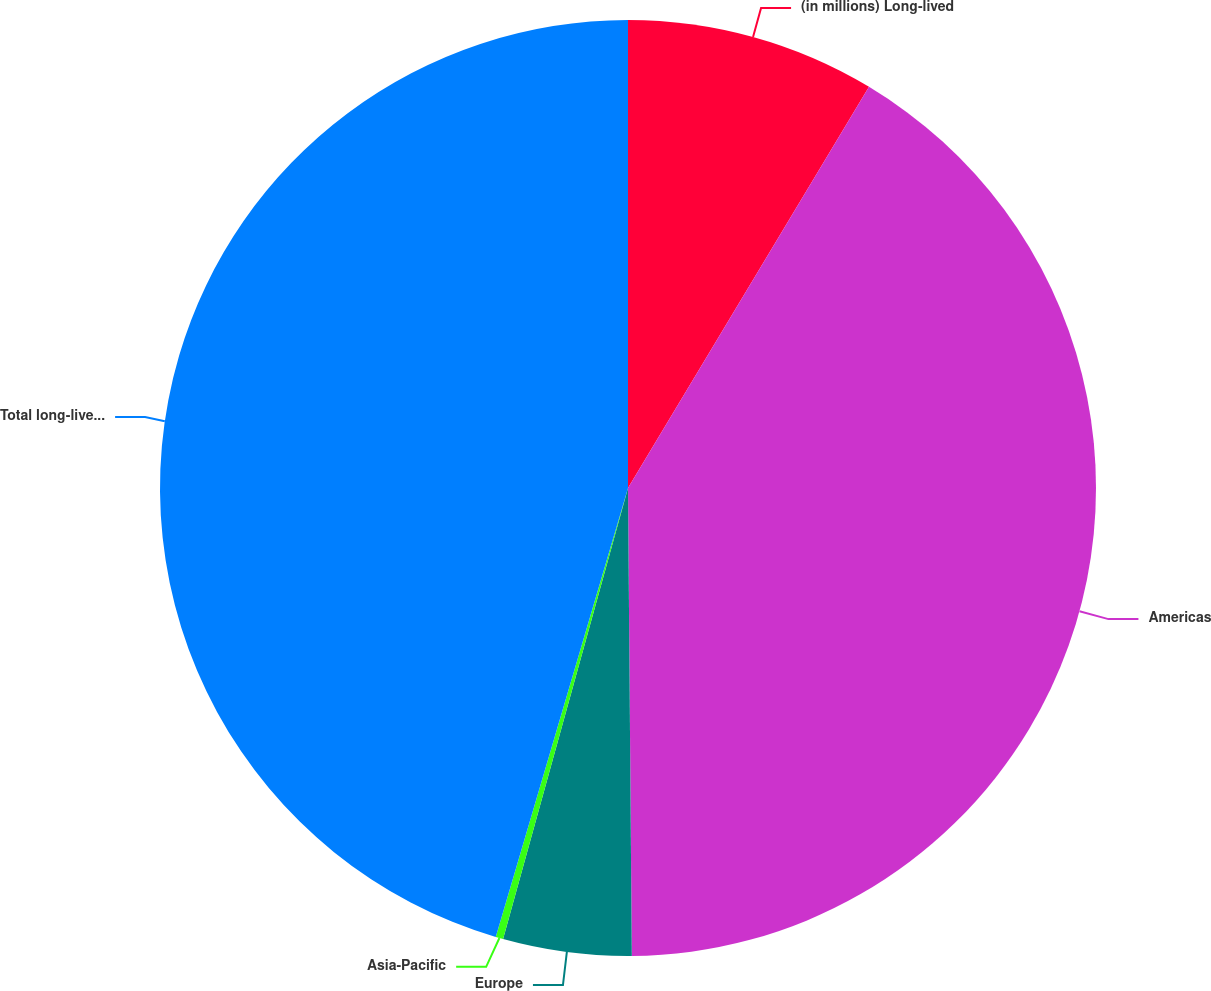Convert chart. <chart><loc_0><loc_0><loc_500><loc_500><pie_chart><fcel>(in millions) Long-lived<fcel>Americas<fcel>Europe<fcel>Asia-Pacific<fcel>Total long-lived assets<nl><fcel>8.61%<fcel>41.26%<fcel>4.43%<fcel>0.26%<fcel>45.44%<nl></chart> 